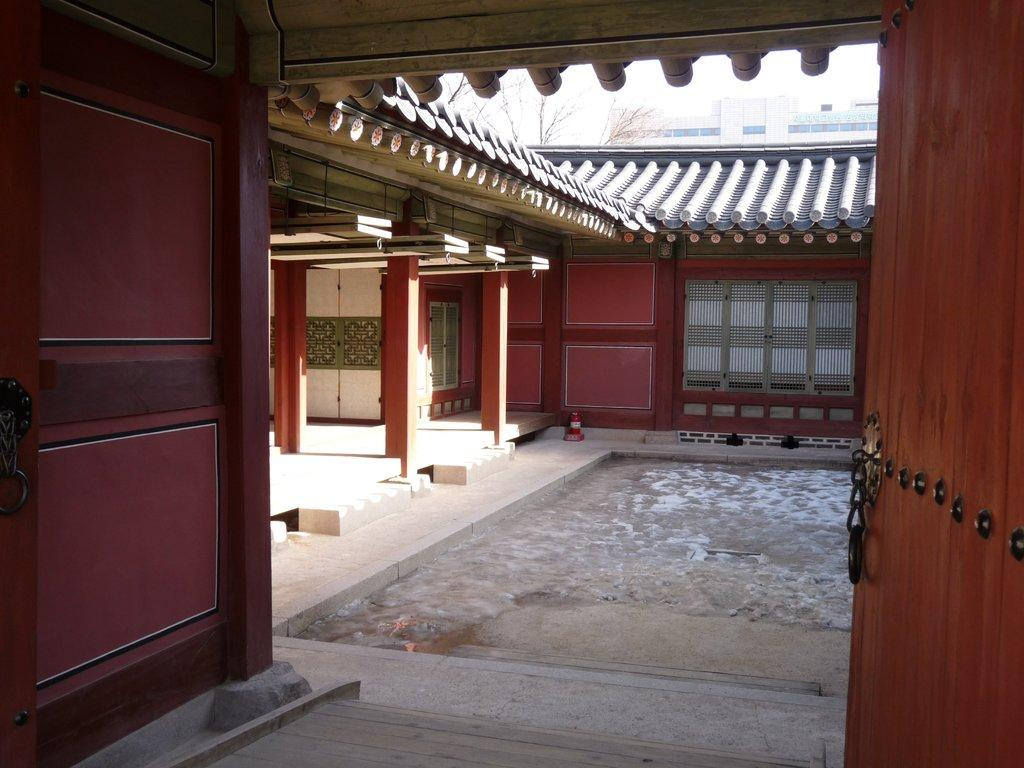What type of location is depicted in the image? The image is an inside picture of a building. What is the main object in the foreground of the image? There is a door in front in the image. What can be seen in the background of the image? There are trees and buildings in the background of the image. What type of minister is seen driving a car in the image? There is no minister or car present in the image; it is an inside picture of a building with a door and background elements. 